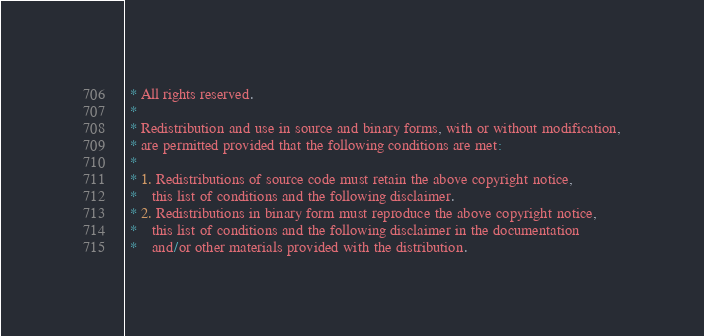<code> <loc_0><loc_0><loc_500><loc_500><_C_> * All rights reserved.
 *
 * Redistribution and use in source and binary forms, with or without modification,
 * are permitted provided that the following conditions are met:
 *
 * 1. Redistributions of source code must retain the above copyright notice,
 *    this list of conditions and the following disclaimer.
 * 2. Redistributions in binary form must reproduce the above copyright notice,
 *    this list of conditions and the following disclaimer in the documentation
 *    and/or other materials provided with the distribution.</code> 